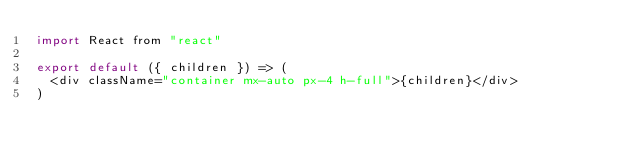<code> <loc_0><loc_0><loc_500><loc_500><_JavaScript_>import React from "react"

export default ({ children }) => (
  <div className="container mx-auto px-4 h-full">{children}</div>
)
</code> 